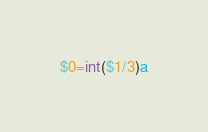<code> <loc_0><loc_0><loc_500><loc_500><_Awk_>$0=int($1/3)a</code> 